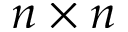<formula> <loc_0><loc_0><loc_500><loc_500>n \times n</formula> 